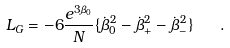<formula> <loc_0><loc_0><loc_500><loc_500>L _ { G } = - 6 \frac { e ^ { 3 \beta _ { 0 } } } { N } \{ \dot { \beta } _ { 0 } ^ { 2 } - \dot { \beta } _ { + } ^ { 2 } - \dot { \beta } _ { - } ^ { 2 } \} \quad .</formula> 